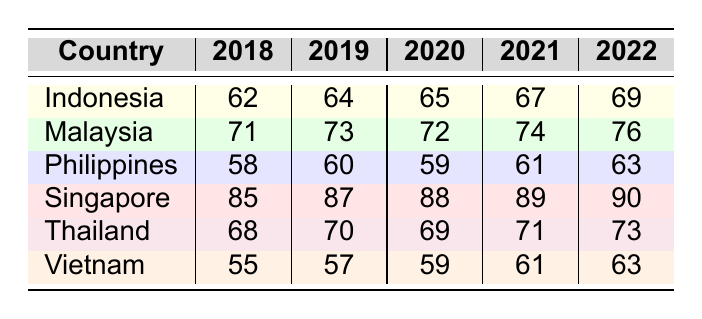What was the environmental policy implementation score for Singapore in 2022? Looking at the table, the score for Singapore in 2022 is directly listed under the year 2022, which shows a score of 90.
Answer: 90 Which country had the highest score in 2019? The table shows that Singapore had the highest implementation score in 2019 with a score of 87 compared to other countries' scores.
Answer: Singapore What is the total score for Indonesia from 2018 to 2022? The implementation scores for Indonesia from 2018 to 2022 are 62, 64, 65, 67, and 69. Adding these scores gives 62 + 64 + 65 + 67 + 69 = 327.
Answer: 327 What is the average score for the Philippines from 2018 to 2022? The scores for the Philippines are 58, 60, 59, 61, and 63. The sum of these scores is 58 + 60 + 59 + 61 + 63 = 301. There are 5 scores, so the average is 301/5 = 60.2.
Answer: 60.2 Did Vietnam have a higher score than Thailand in 2020? The table shows that Vietnam scored 59 and Thailand scored 69 in 2020. Since 59 is less than 69, Vietnam did not have a higher score than Thailand in that year.
Answer: No Which country showed the greatest increase in its score from 2018 to 2022? Analyzing the scores, Indonesia increased from 62 to 69 (an increase of 7), Malaysia from 71 to 76 (an increase of 5), Philippines from 58 to 63 (an increase of 5), Singapore from 85 to 90 (an increase of 5), Thailand from 68 to 73 (an increase of 5), and Vietnam from 55 to 63 (an increase of 8). Vietnam showed the greatest increase of 8 points from 2018 to 2022.
Answer: Vietnam What was the trend for Malaysia's environmental policy implementation scores over the given years? Observing the scores for Malaysia: 71, 73, 72, 74, and 76, we can see that there was an initial increase in 2018 to 2019, a slight decrease in 2020, and then a subsequent increase in 2021 and 2022. Thus, it had a generally upward trend except for a minor dip in 2020.
Answer: Upward trend with a dip in 2020 